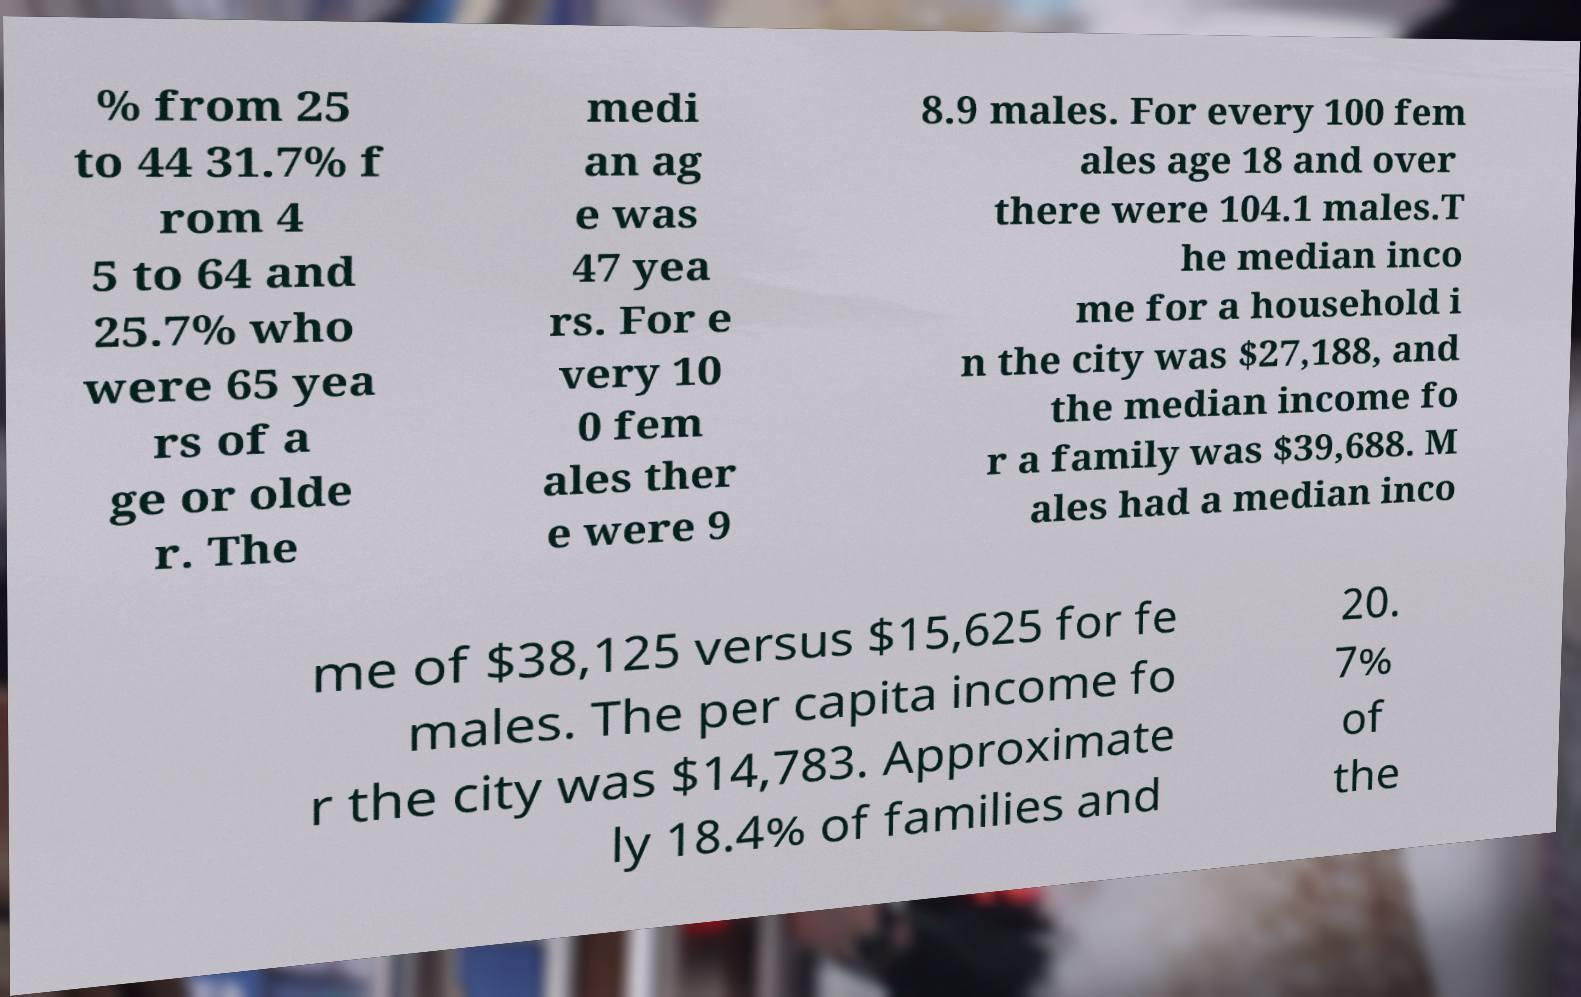For documentation purposes, I need the text within this image transcribed. Could you provide that? % from 25 to 44 31.7% f rom 4 5 to 64 and 25.7% who were 65 yea rs of a ge or olde r. The medi an ag e was 47 yea rs. For e very 10 0 fem ales ther e were 9 8.9 males. For every 100 fem ales age 18 and over there were 104.1 males.T he median inco me for a household i n the city was $27,188, and the median income fo r a family was $39,688. M ales had a median inco me of $38,125 versus $15,625 for fe males. The per capita income fo r the city was $14,783. Approximate ly 18.4% of families and 20. 7% of the 